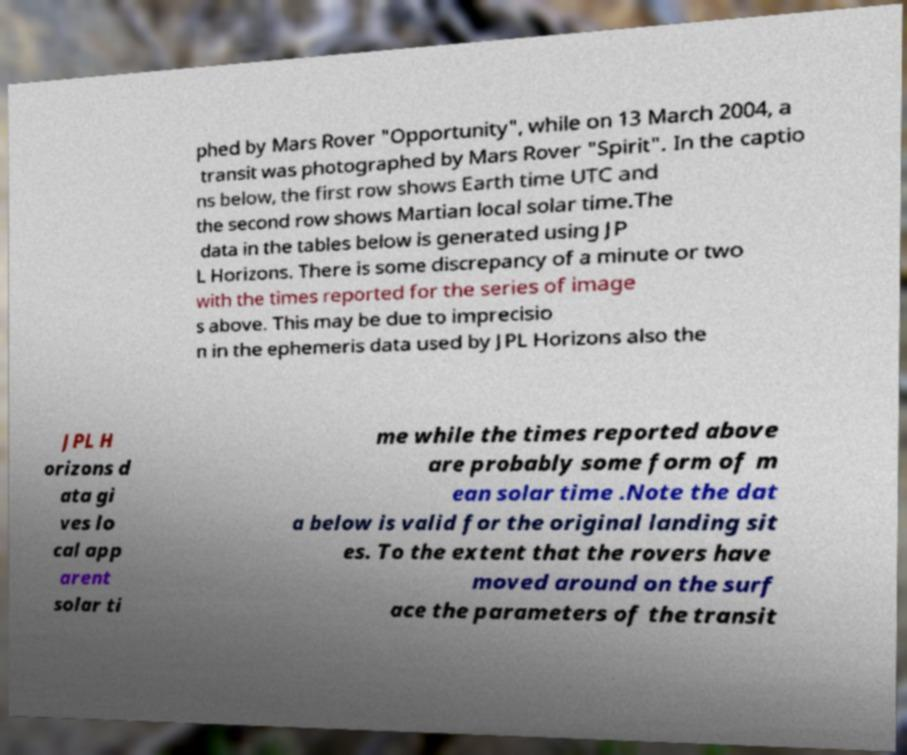Can you read and provide the text displayed in the image?This photo seems to have some interesting text. Can you extract and type it out for me? phed by Mars Rover "Opportunity", while on 13 March 2004, a transit was photographed by Mars Rover "Spirit". In the captio ns below, the first row shows Earth time UTC and the second row shows Martian local solar time.The data in the tables below is generated using JP L Horizons. There is some discrepancy of a minute or two with the times reported for the series of image s above. This may be due to imprecisio n in the ephemeris data used by JPL Horizons also the JPL H orizons d ata gi ves lo cal app arent solar ti me while the times reported above are probably some form of m ean solar time .Note the dat a below is valid for the original landing sit es. To the extent that the rovers have moved around on the surf ace the parameters of the transit 